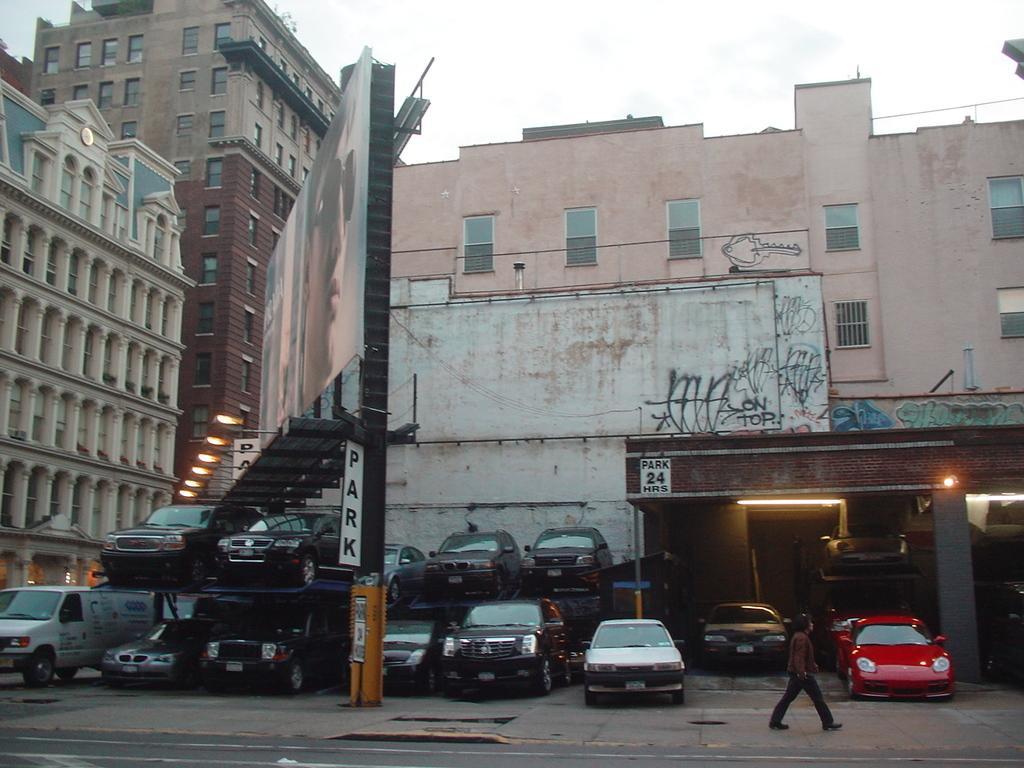In one or two sentences, can you explain what this image depicts? In the image there is a person walking on the footpath with many cars behind him in front of building, on the left side there are street lights followed by buildings in the background and above its sky. 